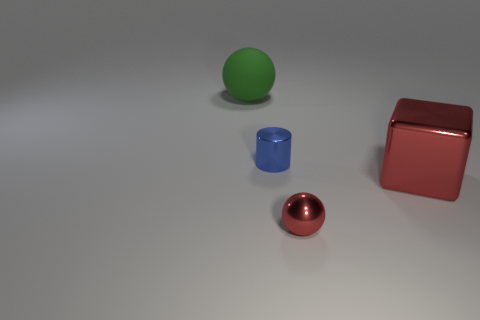There is a sphere that is in front of the green sphere; is it the same size as the big red shiny block?
Give a very brief answer. No. There is a block that is the same size as the green object; what is its material?
Give a very brief answer. Metal. Are there any big shiny things to the left of the shiny object that is to the right of the red thing that is to the left of the red shiny cube?
Provide a short and direct response. No. Is there anything else that is the same shape as the small blue metal object?
Make the answer very short. No. Is the color of the tiny thing that is in front of the metal block the same as the large object in front of the matte object?
Keep it short and to the point. Yes. Are there any tiny metallic cylinders?
Your answer should be very brief. Yes. There is a ball that is in front of the tiny thing that is behind the ball that is to the right of the large rubber ball; what size is it?
Your answer should be compact. Small. There is a tiny red shiny object; is its shape the same as the big thing on the left side of the tiny red ball?
Your answer should be very brief. Yes. Are there any tiny spheres of the same color as the large metallic cube?
Your answer should be very brief. Yes. How many cylinders are either big objects or metallic objects?
Your response must be concise. 1. 